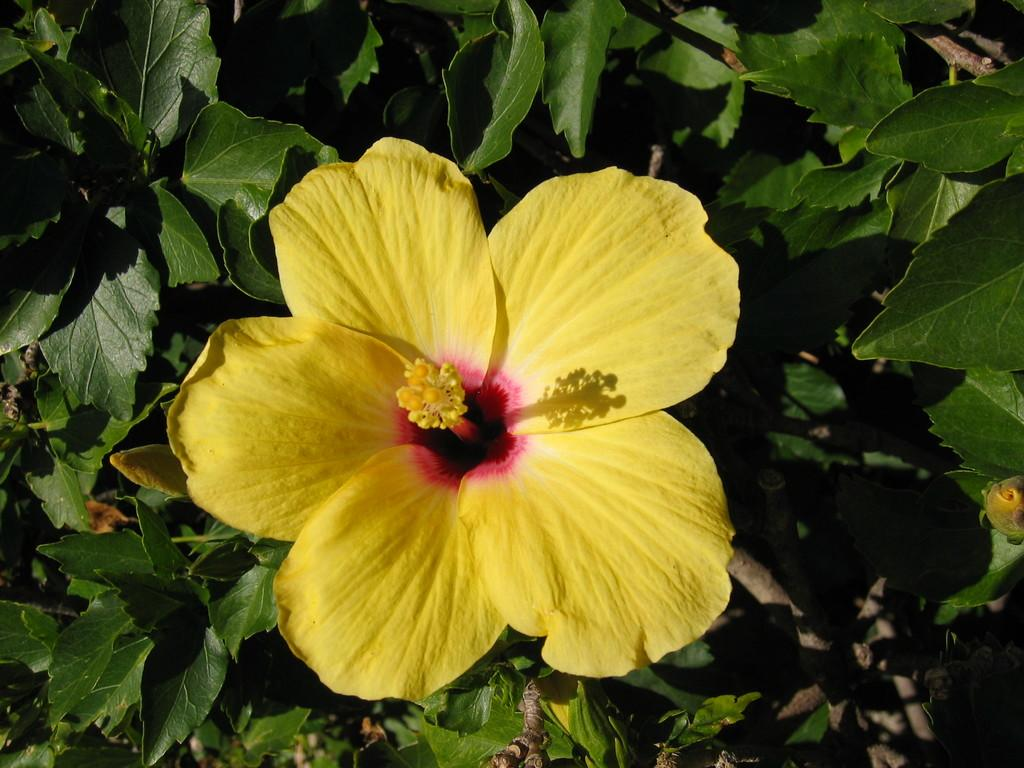What is the main subject of the image? There is a flower in the image. What else can be seen around the flower? There are leaves around the flower. Are there any other plant-related elements in the image? Yes, there are branches in the image. How many pigs are resting in the shade under the flower in the image? There are no pigs present in the image, and the flower does not provide shade. 